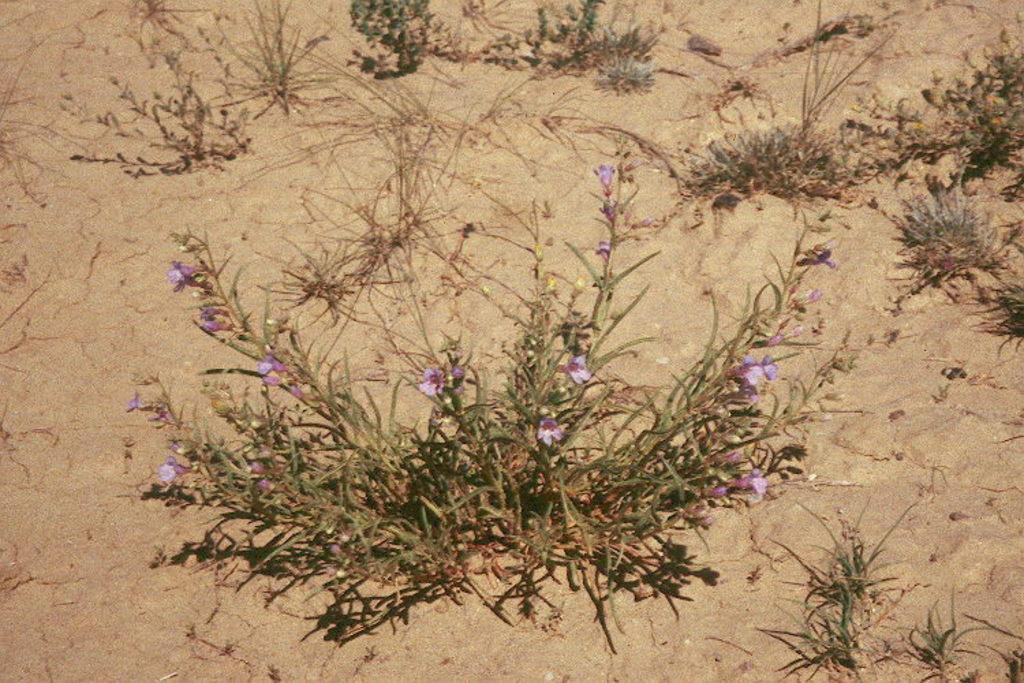What type of surface is visible in the image? The image contains a sand surface. What is present on the sand surface? There are plants and tiny flowers on the sand surface. Who is the owner of the roof in the image? There is no roof present in the image, so it is not possible to determine the owner. 